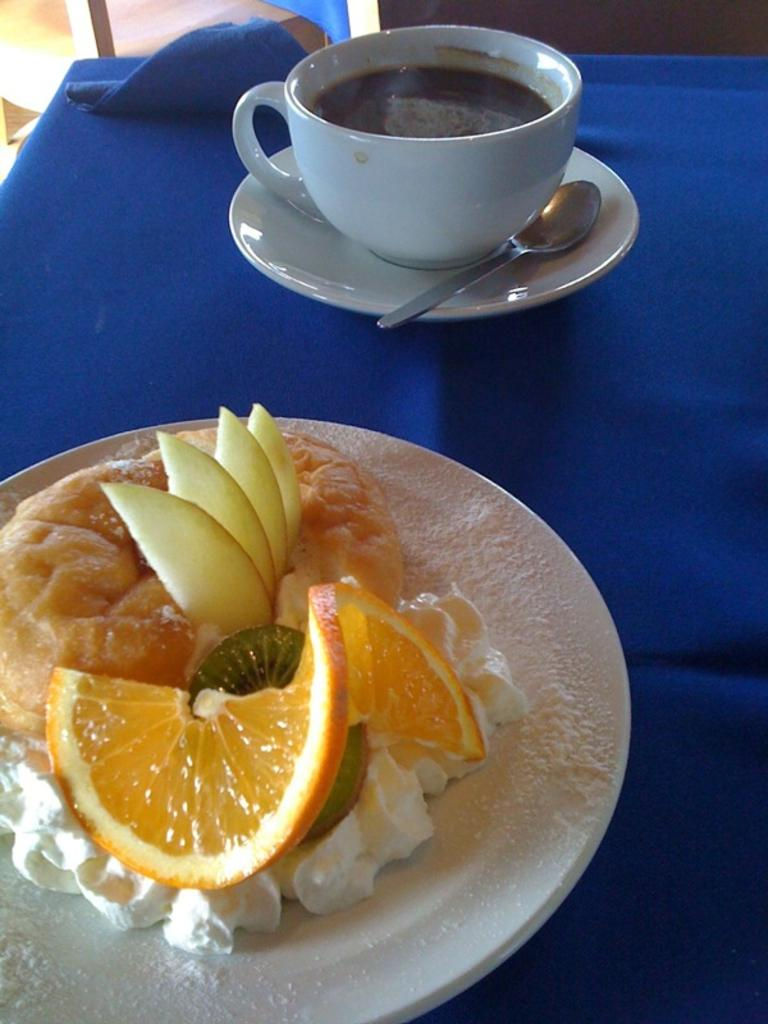What is the main piece of furniture in the image? There is a table in the image. What is placed on the table? There is a plate on the table, and another plate with fruits, cream, and other items. What utensils are present on the table? The plate has a cup and a spoon. What type of mark can be seen on the birthday cake in the image? There is no birthday cake present in the image. 